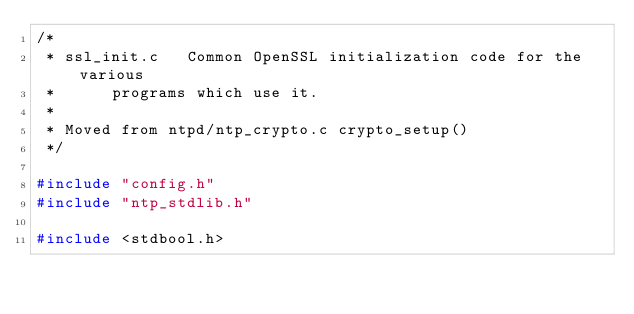<code> <loc_0><loc_0><loc_500><loc_500><_C_>/*
 * ssl_init.c	Common OpenSSL initialization code for the various
 *		programs which use it.
 *
 * Moved from ntpd/ntp_crypto.c crypto_setup()
 */

#include "config.h"
#include "ntp_stdlib.h"

#include <stdbool.h></code> 